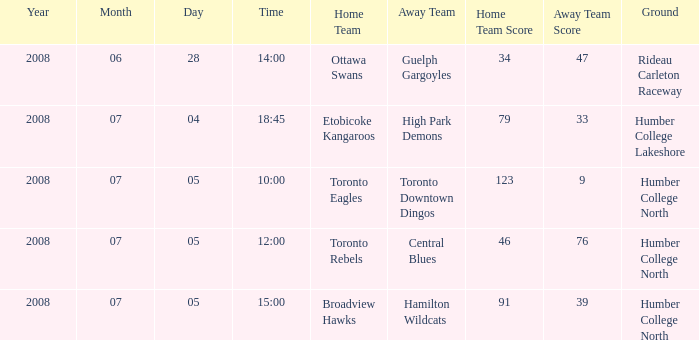What is the Date with a Time that is 18:45? 2008-07-04. 